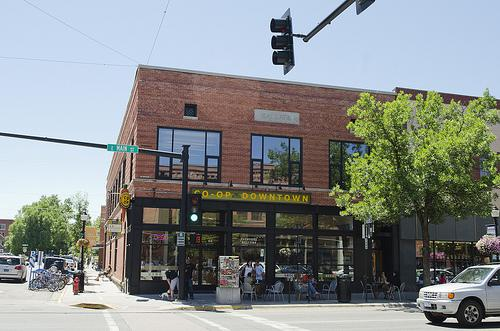Question: what is pictured?
Choices:
A. A restaurant.
B. A garage.
C. A building downtown.
D. An old church.
Answer with the letter. Answer: C Question: how many cars can be seen?
Choices:
A. 2.
B. 5.
C. 4.
D. 6.
Answer with the letter. Answer: C Question: where was this photo taken?
Choices:
A. In front of the pharmacy.
B. Across the street from CO-OP Downtown.
C. Beside the drive-in.
D. Behind the restaurant.
Answer with the letter. Answer: B Question: what is the building made of?
Choices:
A. Concrete.
B. Wood.
C. Brick.
D. Steel.
Answer with the letter. Answer: C 